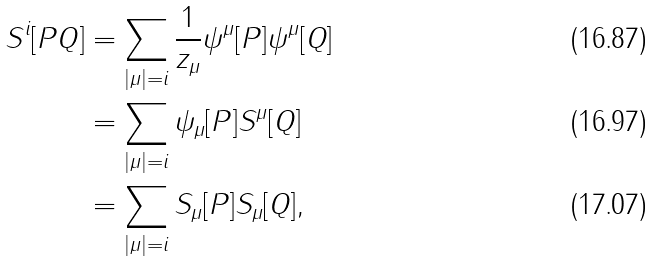Convert formula to latex. <formula><loc_0><loc_0><loc_500><loc_500>S ^ { i } [ P Q ] & = \sum _ { \left | { \mu } \right | = i } \frac { 1 } { z _ { \mu } } \psi ^ { \mu } [ P ] \psi ^ { \mu } [ Q ] \\ & = \sum _ { \left | { \mu } \right | = i } \psi _ { \mu } [ P ] S ^ { \mu } [ Q ] \\ & = \sum _ { \left | { \mu } \right | = i } S _ { \mu } [ P ] S _ { \mu } [ Q ] ,</formula> 